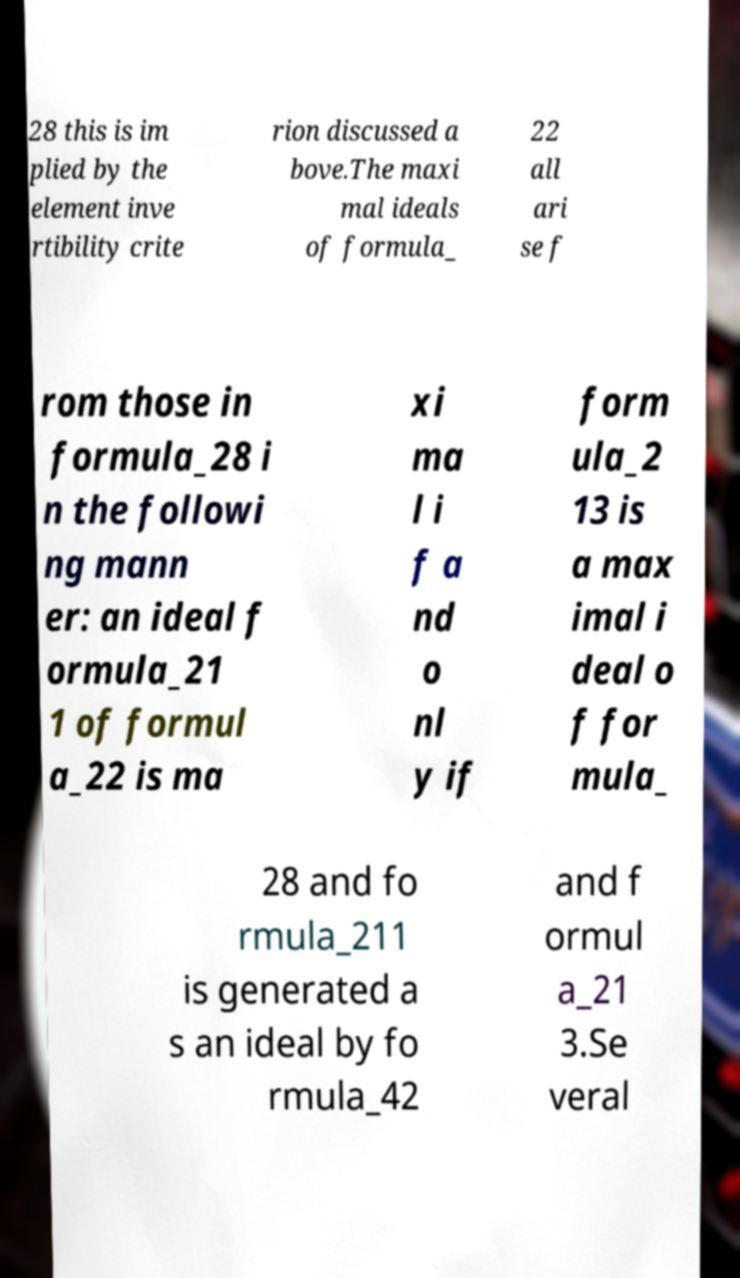Please read and relay the text visible in this image. What does it say? 28 this is im plied by the element inve rtibility crite rion discussed a bove.The maxi mal ideals of formula_ 22 all ari se f rom those in formula_28 i n the followi ng mann er: an ideal f ormula_21 1 of formul a_22 is ma xi ma l i f a nd o nl y if form ula_2 13 is a max imal i deal o f for mula_ 28 and fo rmula_211 is generated a s an ideal by fo rmula_42 and f ormul a_21 3.Se veral 